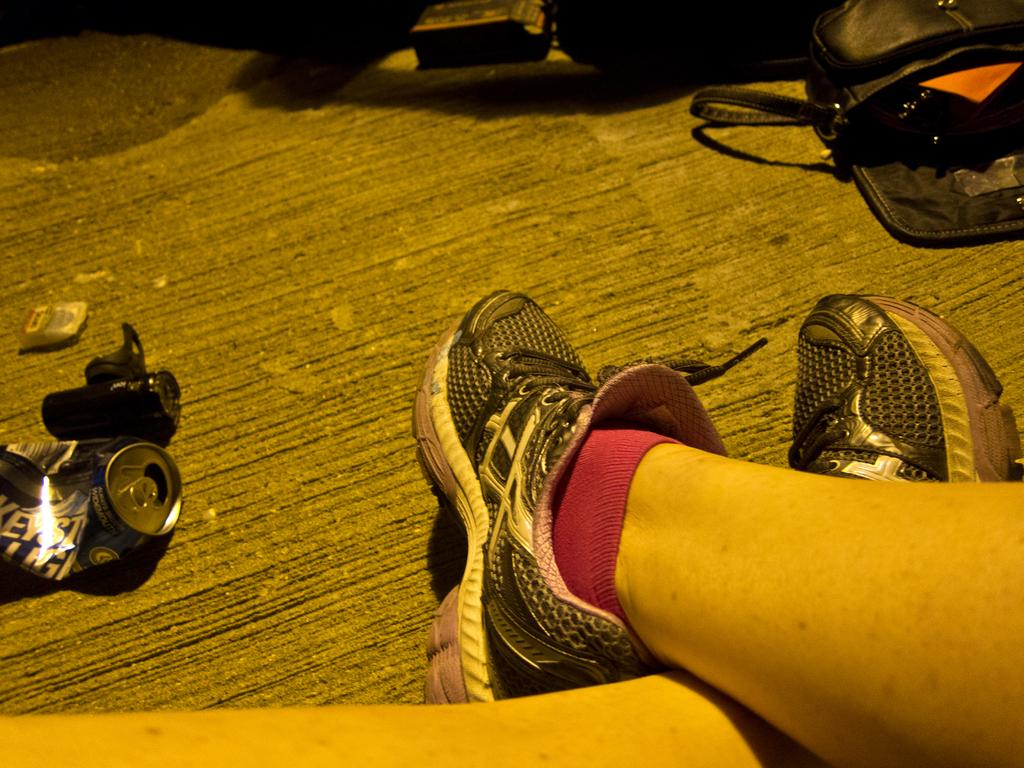What body part is visible in the image? There are person's legs in the image. What type of container is present in the image? There is a beverage tin in the image. What object is on the floor in the image? There is a bag on the floor in the image. What type of expansion can be seen in the image? There is no expansion visible in the image. What system is present in the image? There is no system present in the image. 